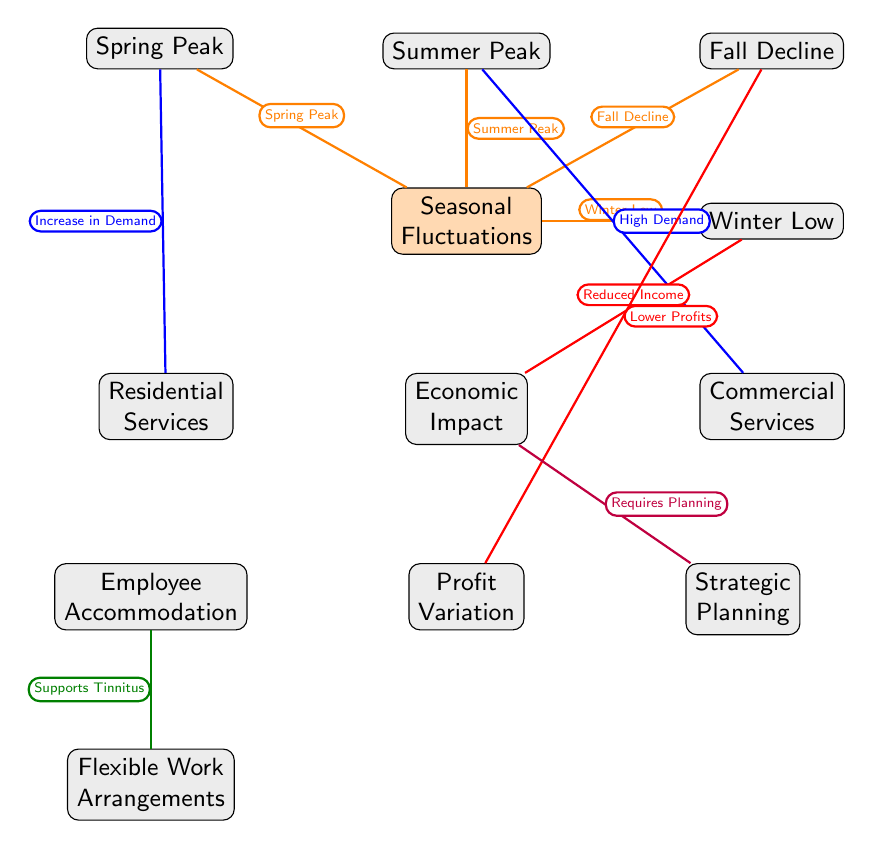What are the four seasonal peaks shown in the diagram? The diagram highlights four specific seasonal peaks: Spring Peak, Summer Peak, Fall Decline, and Winter Low. By identifying the main node "Seasonal Fluctuations," we can trace the connections leading to these seasonal nodes.
Answer: Spring Peak, Summer Peak, Fall Decline, Winter Low Which type of services has an increase in demand during Spring Peak? According to the diagram, the Residential Services are linked to the Spring Peak with an edge labeled as "Increase in Demand." This indicates that during the Spring Peak, demand increases specifically for residential services.
Answer: Residential Services What type of economic effect is associated with Winter Low? The diagram connects Winter Low to Economic Impact with an edge labeled "Reduced Income." This directly indicates that the economic effect during the Winter Low season is a reduction in income.
Answer: Reduced Income How do Employee Accommodations relate to Tinnitus? The diagram shows that Employee Accommodations connect to Flexible Work Arrangements, labeled with "Supports Tinnitus." This suggests that accommodations made for employees, particularly flexible work arrangements, are designed to assist those living with tinnitus.
Answer: Supports Tinnitus What kind of planning is required due to the Economic Impact node? The Economic Impact node links to Strategic Planning, marked with the label "Requires Planning." This highlights the necessity for strategic planning in response to the economic effects illustrated in the diagram.
Answer: Requires Planning What happens to profits during the Fall Decline? The Fall Decline node connects to Profit Variation, with an edge labeled "Lower Profits." This implies that during the Fall season decline, there is an expectation of reduced profits.
Answer: Lower Profits Which node describes services with high demand during the summer? The Summer Peak is connected to Commercial Services with an edge labeled as "High Demand." This directly indicates that the summer season is characterized by high demand for commercial services.
Answer: Commercial Services 